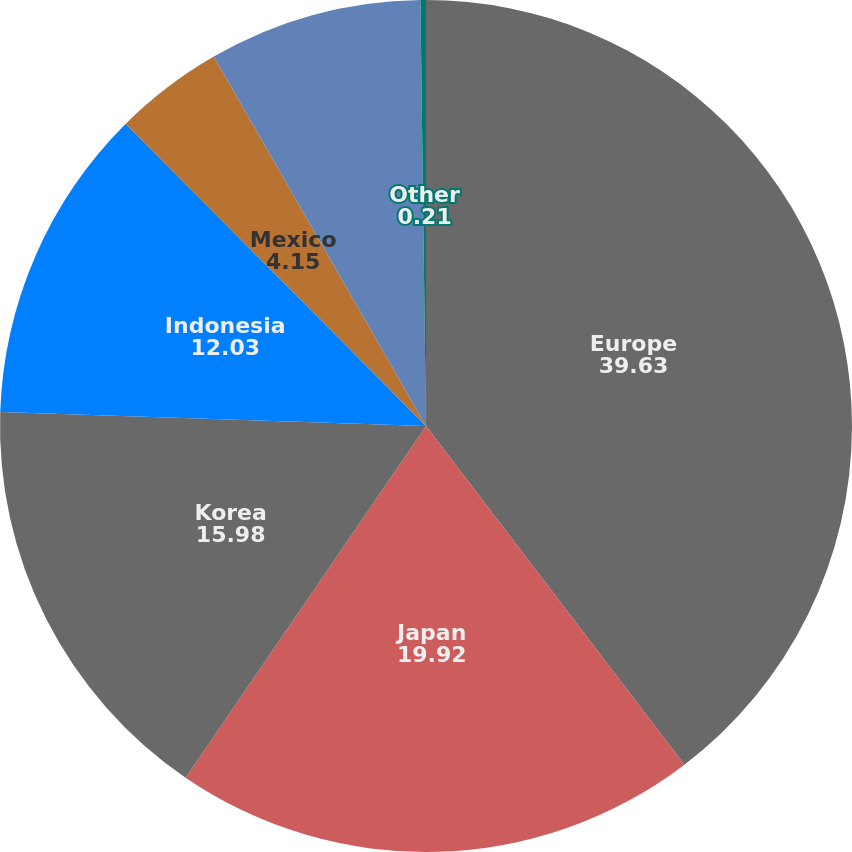Convert chart to OTSL. <chart><loc_0><loc_0><loc_500><loc_500><pie_chart><fcel>Europe<fcel>Japan<fcel>Korea<fcel>Indonesia<fcel>Mexico<fcel>Australia<fcel>Other<nl><fcel>39.63%<fcel>19.92%<fcel>15.98%<fcel>12.03%<fcel>4.15%<fcel>8.09%<fcel>0.21%<nl></chart> 